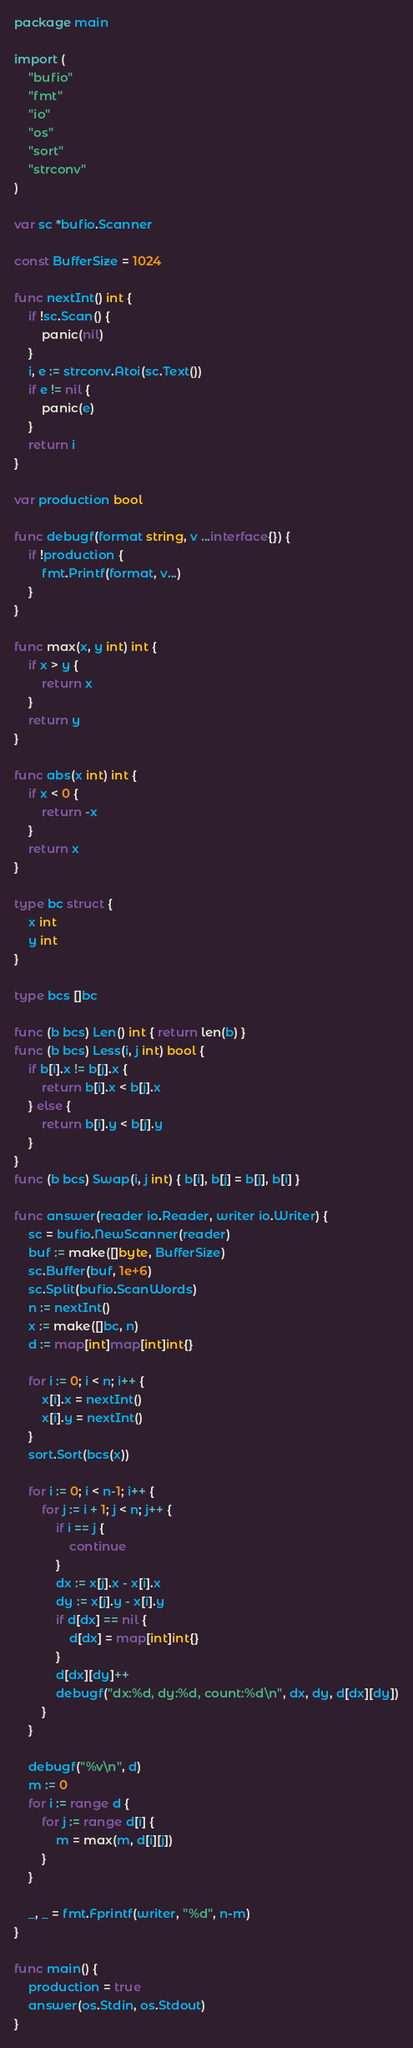<code> <loc_0><loc_0><loc_500><loc_500><_Go_>package main

import (
	"bufio"
	"fmt"
	"io"
	"os"
	"sort"
	"strconv"
)

var sc *bufio.Scanner

const BufferSize = 1024

func nextInt() int {
	if !sc.Scan() {
		panic(nil)
	}
	i, e := strconv.Atoi(sc.Text())
	if e != nil {
		panic(e)
	}
	return i
}

var production bool

func debugf(format string, v ...interface{}) {
	if !production {
		fmt.Printf(format, v...)
	}
}

func max(x, y int) int {
	if x > y {
		return x
	}
	return y
}

func abs(x int) int {
	if x < 0 {
		return -x
	}
	return x
}

type bc struct {
	x int
	y int
}

type bcs []bc

func (b bcs) Len() int { return len(b) }
func (b bcs) Less(i, j int) bool {
	if b[i].x != b[j].x {
		return b[i].x < b[j].x
	} else {
		return b[i].y < b[j].y
	}
}
func (b bcs) Swap(i, j int) { b[i], b[j] = b[j], b[i] }

func answer(reader io.Reader, writer io.Writer) {
	sc = bufio.NewScanner(reader)
	buf := make([]byte, BufferSize)
	sc.Buffer(buf, 1e+6)
	sc.Split(bufio.ScanWords)
	n := nextInt()
	x := make([]bc, n)
	d := map[int]map[int]int{}

	for i := 0; i < n; i++ {
		x[i].x = nextInt()
		x[i].y = nextInt()
	}
	sort.Sort(bcs(x))

	for i := 0; i < n-1; i++ {
		for j := i + 1; j < n; j++ {
			if i == j {
				continue
			}
			dx := x[j].x - x[i].x
			dy := x[j].y - x[i].y
			if d[dx] == nil {
				d[dx] = map[int]int{}
			}
			d[dx][dy]++
			debugf("dx:%d, dy:%d, count:%d\n", dx, dy, d[dx][dy])
		}
	}

	debugf("%v\n", d)
	m := 0
	for i := range d {
		for j := range d[i] {
			m = max(m, d[i][j])
		}
	}

	_, _ = fmt.Fprintf(writer, "%d", n-m)
}

func main() {
	production = true
	answer(os.Stdin, os.Stdout)
}
</code> 